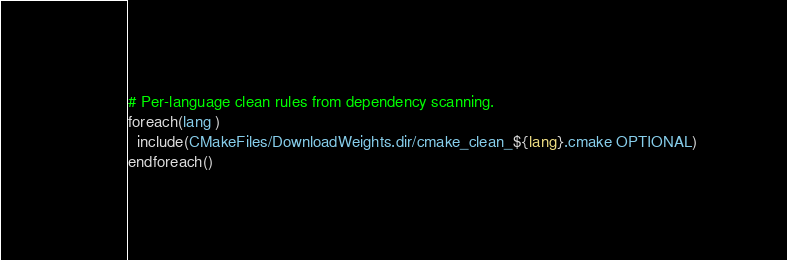<code> <loc_0><loc_0><loc_500><loc_500><_CMake_>
# Per-language clean rules from dependency scanning.
foreach(lang )
  include(CMakeFiles/DownloadWeights.dir/cmake_clean_${lang}.cmake OPTIONAL)
endforeach()
</code> 